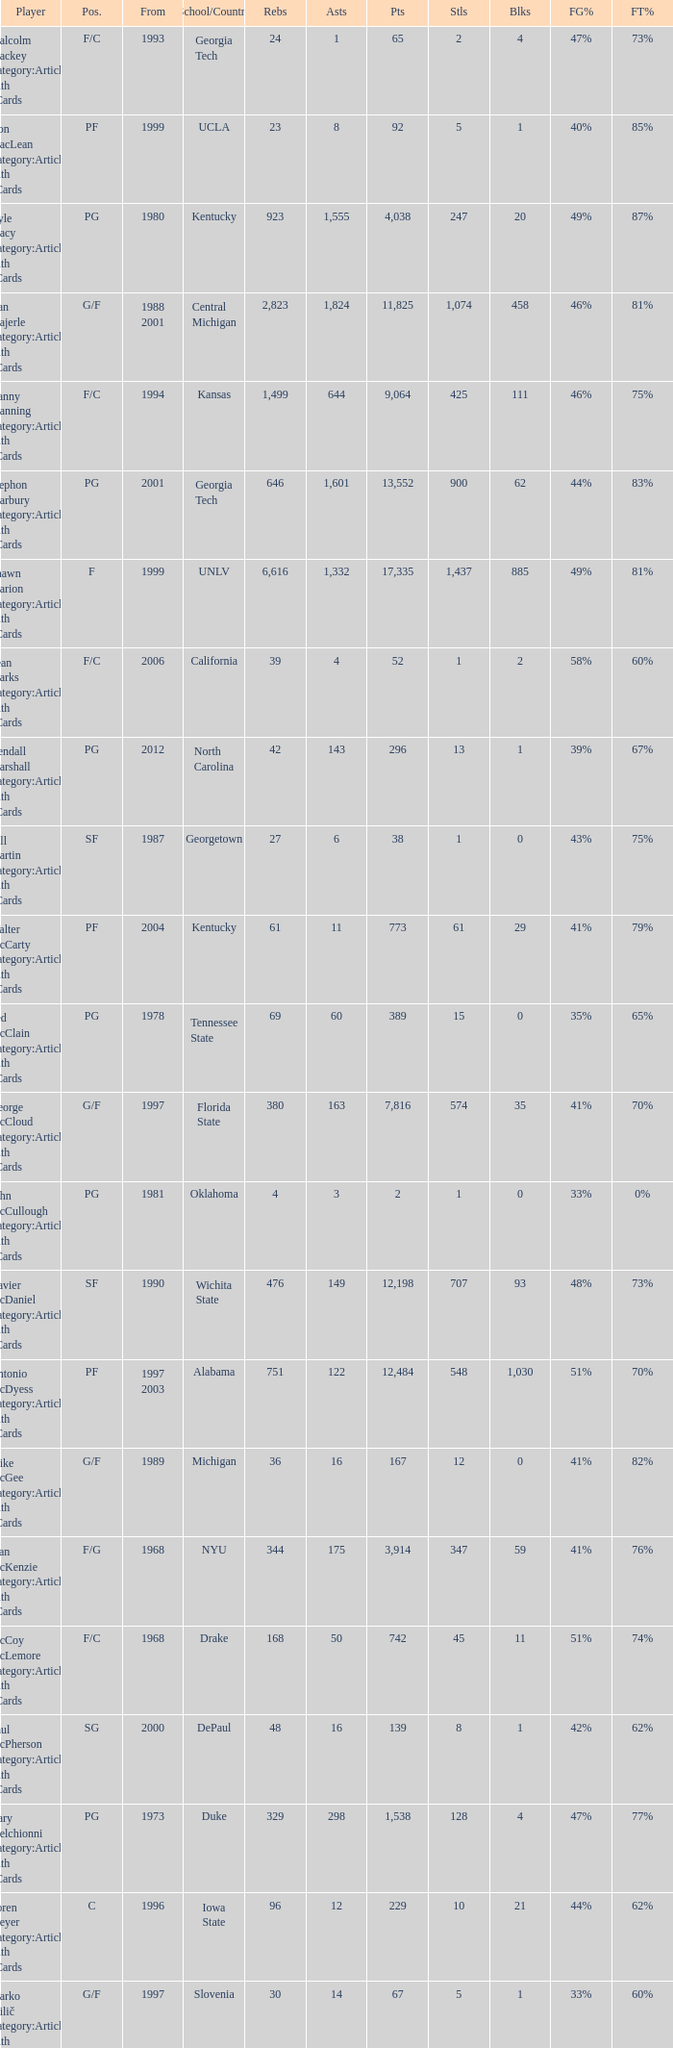Who has the high assists in 2000? 16.0. 